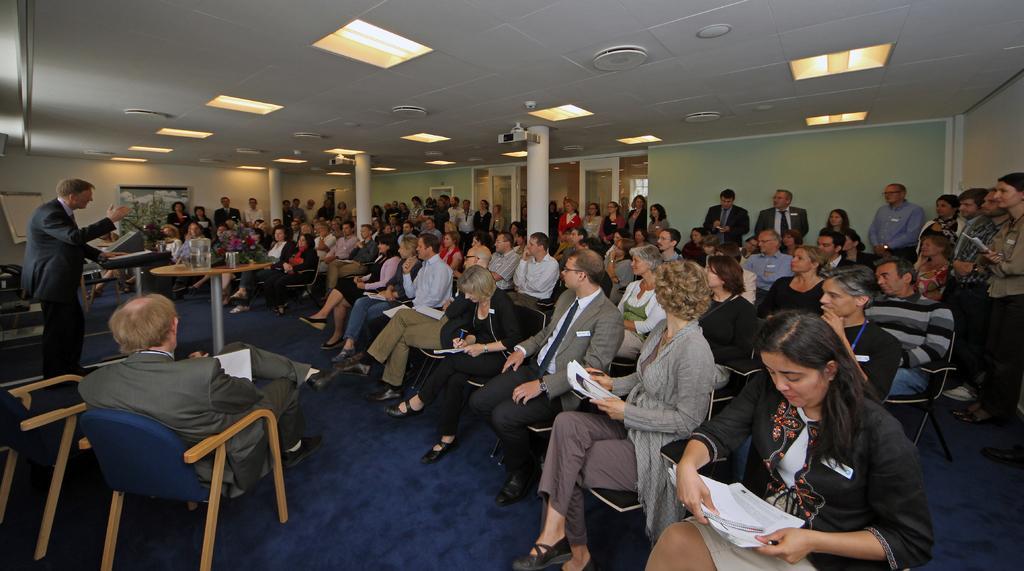How would you summarize this image in a sentence or two? This picture shows a meeting room where all the people seated on the chairs and few are holding papers in their hands and we see a man standing and speaking at a podium and we seek proof water bottles and glasses on the table and we see few men standing on the back and we see a projector and few lights on the roof 